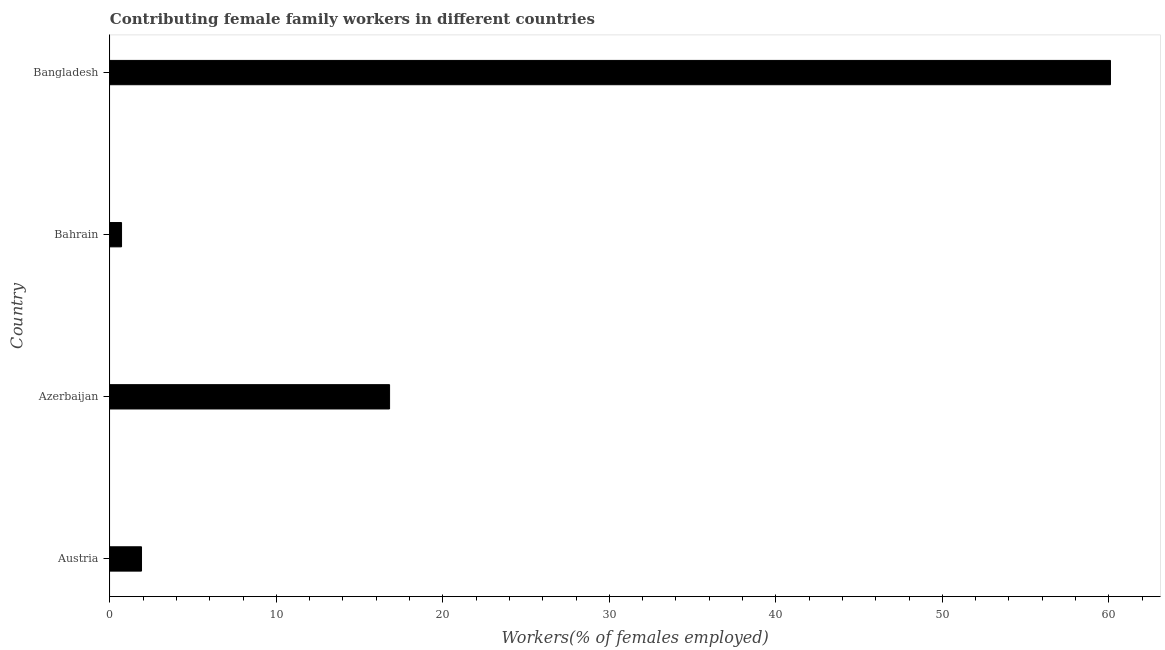Does the graph contain any zero values?
Your response must be concise. No. Does the graph contain grids?
Your answer should be very brief. No. What is the title of the graph?
Your answer should be very brief. Contributing female family workers in different countries. What is the label or title of the X-axis?
Provide a succinct answer. Workers(% of females employed). What is the label or title of the Y-axis?
Offer a very short reply. Country. What is the contributing female family workers in Bangladesh?
Offer a very short reply. 60.1. Across all countries, what is the maximum contributing female family workers?
Ensure brevity in your answer.  60.1. Across all countries, what is the minimum contributing female family workers?
Provide a short and direct response. 0.7. In which country was the contributing female family workers maximum?
Offer a terse response. Bangladesh. In which country was the contributing female family workers minimum?
Offer a very short reply. Bahrain. What is the sum of the contributing female family workers?
Ensure brevity in your answer.  79.5. What is the average contributing female family workers per country?
Your answer should be compact. 19.88. What is the median contributing female family workers?
Your answer should be very brief. 9.35. What is the ratio of the contributing female family workers in Austria to that in Bahrain?
Make the answer very short. 2.71. Is the contributing female family workers in Austria less than that in Bahrain?
Offer a very short reply. No. What is the difference between the highest and the second highest contributing female family workers?
Your answer should be very brief. 43.3. Is the sum of the contributing female family workers in Azerbaijan and Bahrain greater than the maximum contributing female family workers across all countries?
Offer a very short reply. No. What is the difference between the highest and the lowest contributing female family workers?
Make the answer very short. 59.4. How many bars are there?
Keep it short and to the point. 4. How many countries are there in the graph?
Give a very brief answer. 4. What is the difference between two consecutive major ticks on the X-axis?
Your response must be concise. 10. Are the values on the major ticks of X-axis written in scientific E-notation?
Your answer should be compact. No. What is the Workers(% of females employed) of Austria?
Give a very brief answer. 1.9. What is the Workers(% of females employed) in Azerbaijan?
Your answer should be compact. 16.8. What is the Workers(% of females employed) of Bahrain?
Your answer should be very brief. 0.7. What is the Workers(% of females employed) of Bangladesh?
Offer a terse response. 60.1. What is the difference between the Workers(% of females employed) in Austria and Azerbaijan?
Offer a very short reply. -14.9. What is the difference between the Workers(% of females employed) in Austria and Bahrain?
Offer a very short reply. 1.2. What is the difference between the Workers(% of females employed) in Austria and Bangladesh?
Offer a very short reply. -58.2. What is the difference between the Workers(% of females employed) in Azerbaijan and Bahrain?
Your answer should be compact. 16.1. What is the difference between the Workers(% of females employed) in Azerbaijan and Bangladesh?
Your answer should be compact. -43.3. What is the difference between the Workers(% of females employed) in Bahrain and Bangladesh?
Ensure brevity in your answer.  -59.4. What is the ratio of the Workers(% of females employed) in Austria to that in Azerbaijan?
Offer a very short reply. 0.11. What is the ratio of the Workers(% of females employed) in Austria to that in Bahrain?
Provide a succinct answer. 2.71. What is the ratio of the Workers(% of females employed) in Austria to that in Bangladesh?
Offer a very short reply. 0.03. What is the ratio of the Workers(% of females employed) in Azerbaijan to that in Bahrain?
Ensure brevity in your answer.  24. What is the ratio of the Workers(% of females employed) in Azerbaijan to that in Bangladesh?
Keep it short and to the point. 0.28. What is the ratio of the Workers(% of females employed) in Bahrain to that in Bangladesh?
Ensure brevity in your answer.  0.01. 